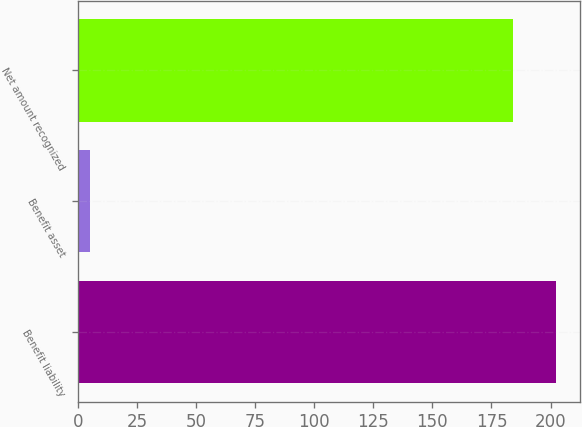<chart> <loc_0><loc_0><loc_500><loc_500><bar_chart><fcel>Benefit liability<fcel>Benefit asset<fcel>Net amount recognized<nl><fcel>202.4<fcel>5<fcel>184<nl></chart> 